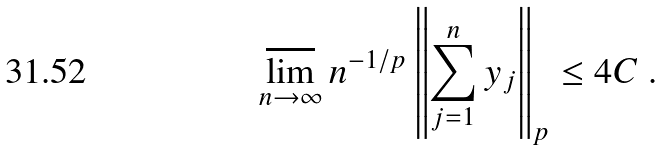Convert formula to latex. <formula><loc_0><loc_0><loc_500><loc_500>\varlimsup _ { n \to \infty } n ^ { - 1 / p } \left \| \sum _ { j = 1 } ^ { n } y _ { j } \right \| _ { p } \leq 4 C \ .</formula> 